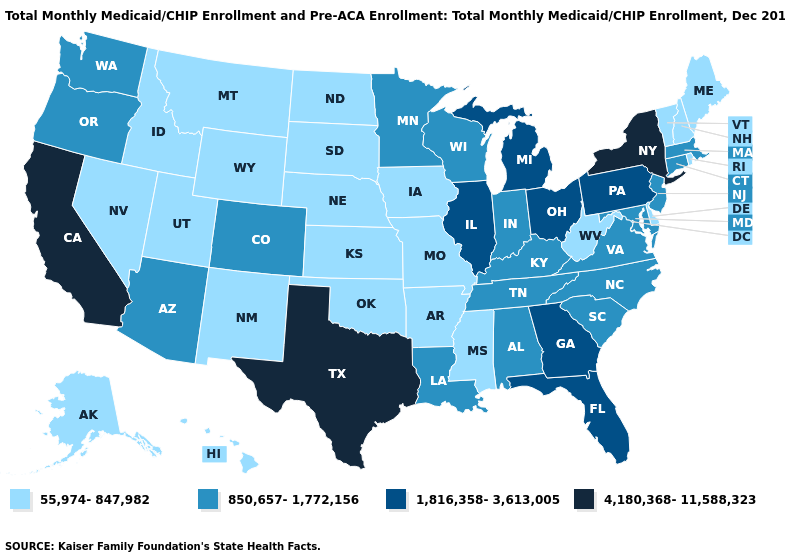What is the lowest value in the USA?
Concise answer only. 55,974-847,982. What is the value of West Virginia?
Short answer required. 55,974-847,982. Which states hav the highest value in the West?
Be succinct. California. What is the lowest value in the MidWest?
Answer briefly. 55,974-847,982. What is the value of Pennsylvania?
Answer briefly. 1,816,358-3,613,005. Name the states that have a value in the range 55,974-847,982?
Short answer required. Alaska, Arkansas, Delaware, Hawaii, Idaho, Iowa, Kansas, Maine, Mississippi, Missouri, Montana, Nebraska, Nevada, New Hampshire, New Mexico, North Dakota, Oklahoma, Rhode Island, South Dakota, Utah, Vermont, West Virginia, Wyoming. What is the value of West Virginia?
Quick response, please. 55,974-847,982. What is the lowest value in states that border South Dakota?
Quick response, please. 55,974-847,982. Which states hav the highest value in the South?
Quick response, please. Texas. What is the lowest value in states that border Maryland?
Be succinct. 55,974-847,982. What is the value of Arkansas?
Concise answer only. 55,974-847,982. What is the highest value in states that border Nevada?
Answer briefly. 4,180,368-11,588,323. What is the highest value in the MidWest ?
Answer briefly. 1,816,358-3,613,005. Among the states that border Kentucky , does Ohio have the highest value?
Write a very short answer. Yes. Name the states that have a value in the range 55,974-847,982?
Give a very brief answer. Alaska, Arkansas, Delaware, Hawaii, Idaho, Iowa, Kansas, Maine, Mississippi, Missouri, Montana, Nebraska, Nevada, New Hampshire, New Mexico, North Dakota, Oklahoma, Rhode Island, South Dakota, Utah, Vermont, West Virginia, Wyoming. 